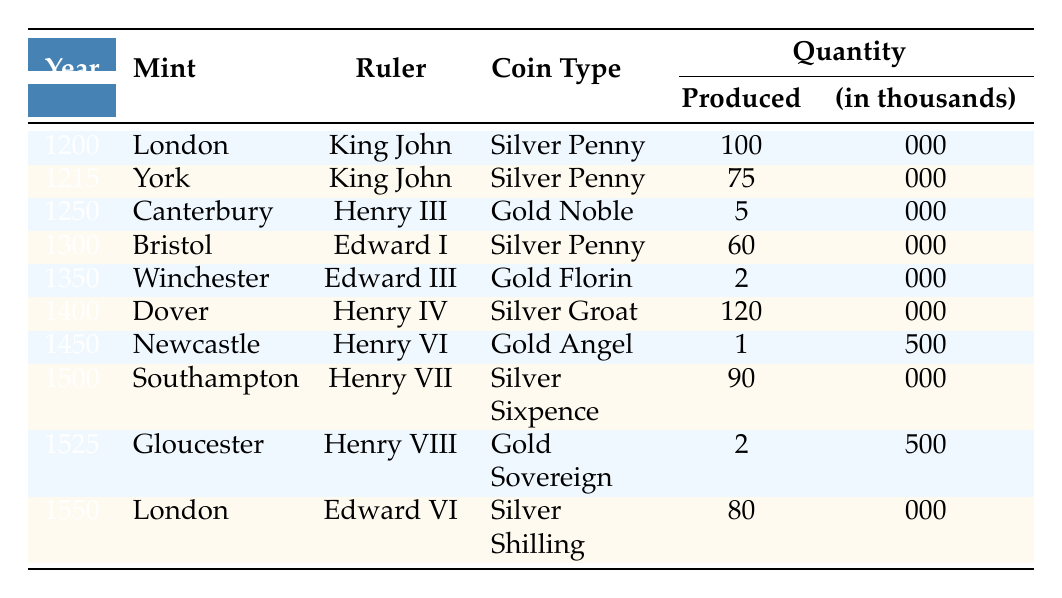What was the coin type produced in London in the year 1200? The table shows that in the year 1200, London produced a Silver Penny.
Answer: Silver Penny Which mint produced the highest quantity of coins in the table? By examining the 'Quantity Produced' column, Dover produced 120,000 coins in 1400, which is the highest compared to other mints in the table.
Answer: Dover How many Silver Pennies were produced overall? The total quantity of Silver Pennies from the table is calculated by summing the quantities: 100,000 (London, 1200) + 75,000 (York, 1215) + 60,000 (Bristol, 1300) + 90,000 (Southampton, 1500) = 325,000.
Answer: 325,000 Is it true that York produced coins under King Henry III? Checking the table entries for York shows that it produced coins under King John in 1215, not King Henry III. Therefore, the statement is false.
Answer: False What was the average quantity produced for Gold coins? The Gold coins listed in the table are the Gold Noble (5,000), Gold Florin (2,000), Gold Angel (1,500), and Gold Sovereign (2,500). The total is 11,000 (5,000 + 2,000 + 1,500 + 2,500) and the average for 4 Gold coin types is 11,000/4 = 2,750.
Answer: 2,750 Which ruler had the smallest quantity of produced coins? Analyzing the 'Quantity Produced' column, Newcastle under Henry VI had the smallest quantity of just 1,500 coins in 1450.
Answer: Henry VI Did any mint produce coins in both the 1200s and 1500s? The table shows that London produced coins in 1200 (Silver Penny) and again in 1550 (Silver Shilling). Therefore, the answer is yes.
Answer: Yes How many more coins were produced in 1400 compared to 1250? In 1400, 120,000 coins were produced at Dover, and in 1250, 5,000 coins were produced at Canterbury. The difference is 120,000 - 5,000 = 115,000.
Answer: 115,000 What percentage of the total coin production in the table was from the mint in Winchester? The total coins produced per the table are 100,000 + 75,000 + 5,000 + 60,000 + 2,000 + 120,000 + 1,500 + 90,000 + 2,500 + 80,000 = 432,000. Winchester produced 2,000 coins in 1350. The percentage is (2,000 / 432,000) * 100 = 0.46%.
Answer: 0.46% 